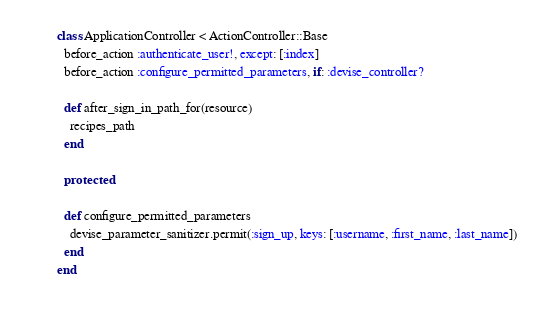<code> <loc_0><loc_0><loc_500><loc_500><_Ruby_>class ApplicationController < ActionController::Base
  before_action :authenticate_user!, except: [:index]
  before_action :configure_permitted_parameters, if: :devise_controller?

  def after_sign_in_path_for(resource)
    recipes_path
  end

  protected 

  def configure_permitted_parameters
    devise_parameter_sanitizer.permit(:sign_up, keys: [:username, :first_name, :last_name])
  end
end
</code> 